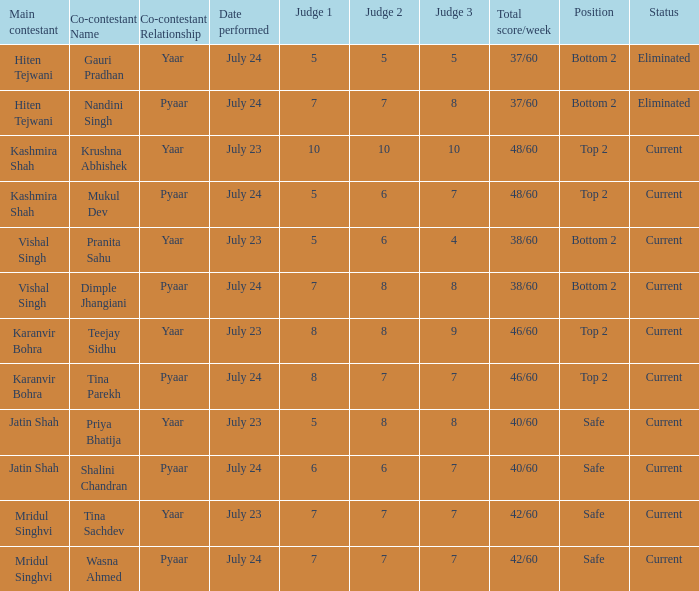Who is the main contestant with a total score/week of 42/60 and a co-contestant (Yaar vs. Pyaa) of Tina Sachdev? Mridul Singhvi. 